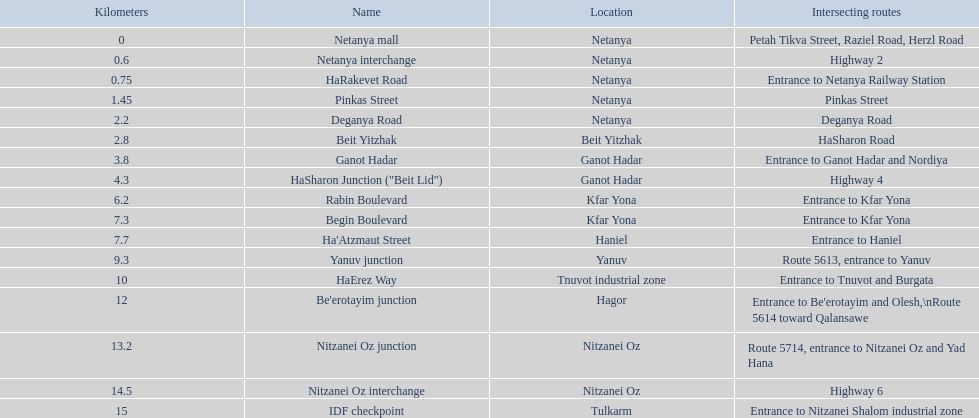What are all of the various segments? Netanya mall, Netanya interchange, HaRakevet Road, Pinkas Street, Deganya Road, Beit Yitzhak, Ganot Hadar, HaSharon Junction ("Beit Lid"), Rabin Boulevard, Begin Boulevard, Ha'Atzmaut Street, Yanuv junction, HaErez Way, Be'erotayim junction, Nitzanei Oz junction, Nitzanei Oz interchange, IDF checkpoint. What is the crossing path for rabin boulevard? Entrance to Kfar Yona. What segment also has a crossing path of entry to kfar yona? Begin Boulevard. 